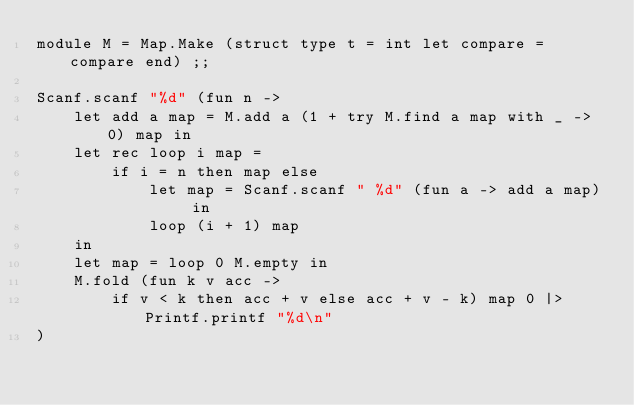<code> <loc_0><loc_0><loc_500><loc_500><_OCaml_>module M = Map.Make (struct type t = int let compare = compare end) ;;

Scanf.scanf "%d" (fun n ->
    let add a map = M.add a (1 + try M.find a map with _ -> 0) map in
    let rec loop i map =
        if i = n then map else
            let map = Scanf.scanf " %d" (fun a -> add a map) in
            loop (i + 1) map
    in
    let map = loop 0 M.empty in
    M.fold (fun k v acc ->
        if v < k then acc + v else acc + v - k) map 0 |> Printf.printf "%d\n"
)</code> 